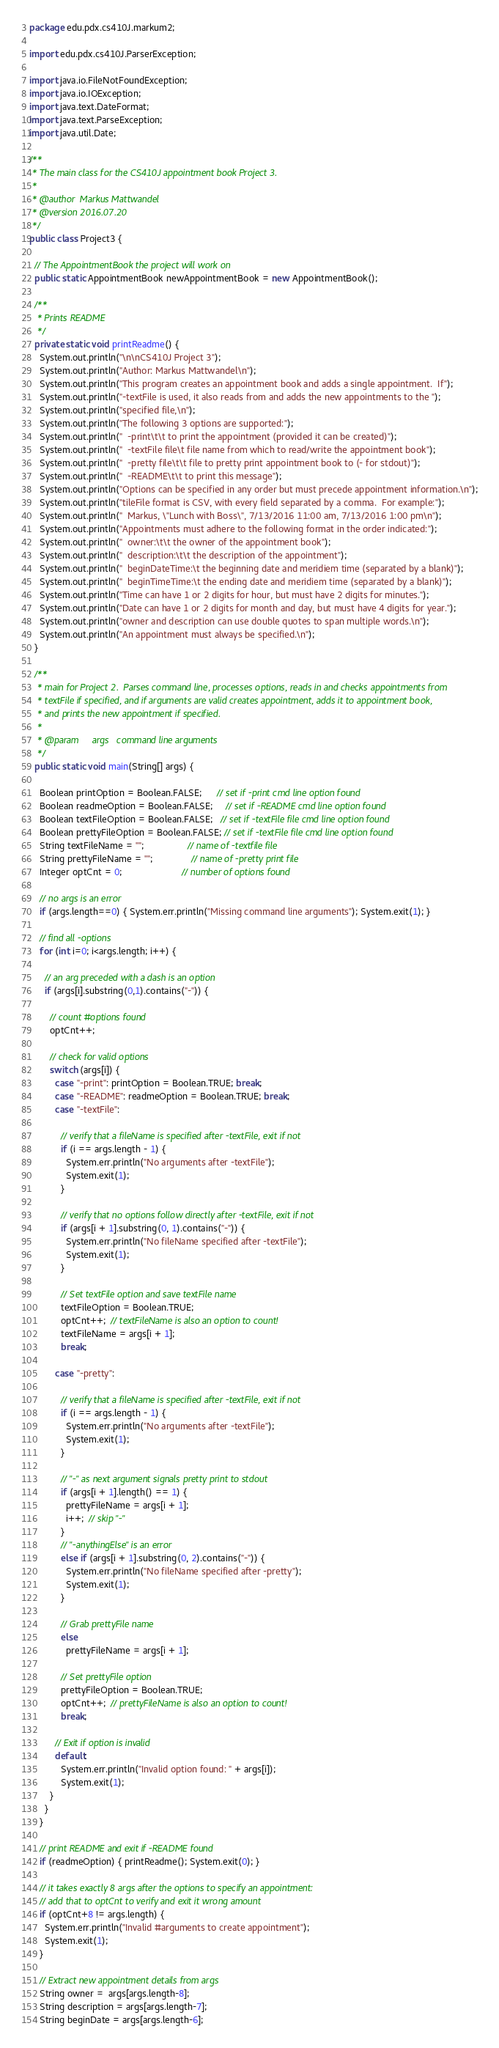<code> <loc_0><loc_0><loc_500><loc_500><_Java_>package edu.pdx.cs410J.markum2;

import edu.pdx.cs410J.ParserException;

import java.io.FileNotFoundException;
import java.io.IOException;
import java.text.DateFormat;
import java.text.ParseException;
import java.util.Date;

/**
 * The main class for the CS410J appointment book Project 3.
 *
 * @author  Markus Mattwandel
 * @version 2016.07.20
 */
public class Project3 {

  // The AppointmentBook the project will work on
  public static AppointmentBook newAppointmentBook = new AppointmentBook();

  /**
   * Prints README
   */
  private static void printReadme() {
    System.out.println("\n\nCS410J Project 3");
    System.out.println("Author: Markus Mattwandel\n");
    System.out.println("This program creates an appointment book and adds a single appointment.  If");
    System.out.println("-textFile is used, it also reads from and adds the new appointments to the ");
    System.out.println("specified file,\n");
    System.out.println("The following 3 options are supported:");
    System.out.println("  -print\t\t to print the appointment (provided it can be created)");
    System.out.println("  -textFile file\t file name from which to read/write the appointment book");
    System.out.println("  -pretty file\t\t file to pretty print appointment book to (- for stdout)");
    System.out.println("  -README\t\t to print this message");
    System.out.println("Options can be specified in any order but must precede appointment information.\n");
    System.out.println("tileFile format is CSV, with every field separated by a comma.  For example:");
    System.out.println("  Markus, \"Lunch with Boss\", 7/13/2016 11:00 am, 7/13/2016 1:00 pm\n");
    System.out.println("Appointments must adhere to the following format in the order indicated:");
    System.out.println("  owner:\t\t the owner of the appointment book");
    System.out.println("  description:\t\t the description of the appointment");
    System.out.println("  beginDateTime:\t the beginning date and meridiem time (separated by a blank)");
    System.out.println("  beginTimeTime:\t the ending date and meridiem time (separated by a blank)");
    System.out.println("Time can have 1 or 2 digits for hour, but must have 2 digits for minutes.");
    System.out.println("Date can have 1 or 2 digits for month and day, but must have 4 digits for year.");
    System.out.println("owner and description can use double quotes to span multiple words.\n");
    System.out.println("An appointment must always be specified.\n");
  }

  /**
   * main for Project 2.  Parses command line, processes options, reads in and checks appointments from
   * textFile if specified, and if arguments are valid creates appointment, adds it to appointment book,
   * and prints the new appointment if specified.
   *
   * @param     args   command line arguments
   */
  public static void main(String[] args) {

    Boolean printOption = Boolean.FALSE;      // set if -print cmd line option found
    Boolean readmeOption = Boolean.FALSE;     // set if -README cmd line option found
    Boolean textFileOption = Boolean.FALSE;   // set if -textFile file cmd line option found
    Boolean prettyFileOption = Boolean.FALSE; // set if -textFile file cmd line option found
    String textFileName = "";                 // name of -textfile file
    String prettyFileName = "";               // name of -pretty print file
    Integer optCnt = 0;                       // number of options found

    // no args is an error
    if (args.length==0) { System.err.println("Missing command line arguments"); System.exit(1); }

    // find all -options
    for (int i=0; i<args.length; i++) {

      // an arg preceded with a dash is an option
      if (args[i].substring(0,1).contains("-")) {

        // count #options found
        optCnt++;

        // check for valid options
        switch (args[i]) {
          case "-print": printOption = Boolean.TRUE; break;
          case "-README": readmeOption = Boolean.TRUE; break;
          case "-textFile":

            // verify that a fileName is specified after -textFile, exit if not
            if (i == args.length - 1) {
              System.err.println("No arguments after -textFile");
              System.exit(1);
            }

            // verify that no options follow directly after -textFile, exit if not
            if (args[i + 1].substring(0, 1).contains("-")) {
              System.err.println("No fileName specified after -textFile");
              System.exit(1);
            }

            // Set textFile option and save textFile name
            textFileOption = Boolean.TRUE;
            optCnt++;  // textFileName is also an option to count!
            textFileName = args[i + 1];
            break;

          case "-pretty":

            // verify that a fileName is specified after -textFile, exit if not
            if (i == args.length - 1) {
              System.err.println("No arguments after -textFile");
              System.exit(1);
            }

            // "-" as next argument signals pretty print to stdout
            if (args[i + 1].length() == 1) {
              prettyFileName = args[i + 1];
              i++;  // skip "-"
            }
            // "-anythingElse" is an error
            else if (args[i + 1].substring(0, 2).contains("-")) {
              System.err.println("No fileName specified after -pretty");
              System.exit(1);
            }

            // Grab prettyFile name
            else
              prettyFileName = args[i + 1];

            // Set prettyFile option
            prettyFileOption = Boolean.TRUE;
            optCnt++;  // prettyFileName is also an option to count!
            break;

          // Exit if option is invalid
          default:
            System.err.println("Invalid option found: " + args[i]);
            System.exit(1);
        }
      }
    }

    // print README and exit if -README found
    if (readmeOption) { printReadme(); System.exit(0); }

    // it takes exactly 8 args after the options to specify an appointment:
    // add that to optCnt to verify and exit it wrong amount
    if (optCnt+8 != args.length) {
      System.err.println("Invalid #arguments to create appointment");
      System.exit(1);
    }

    // Extract new appointment details from args
    String owner =  args[args.length-8];
    String description = args[args.length-7];
    String beginDate = args[args.length-6];</code> 